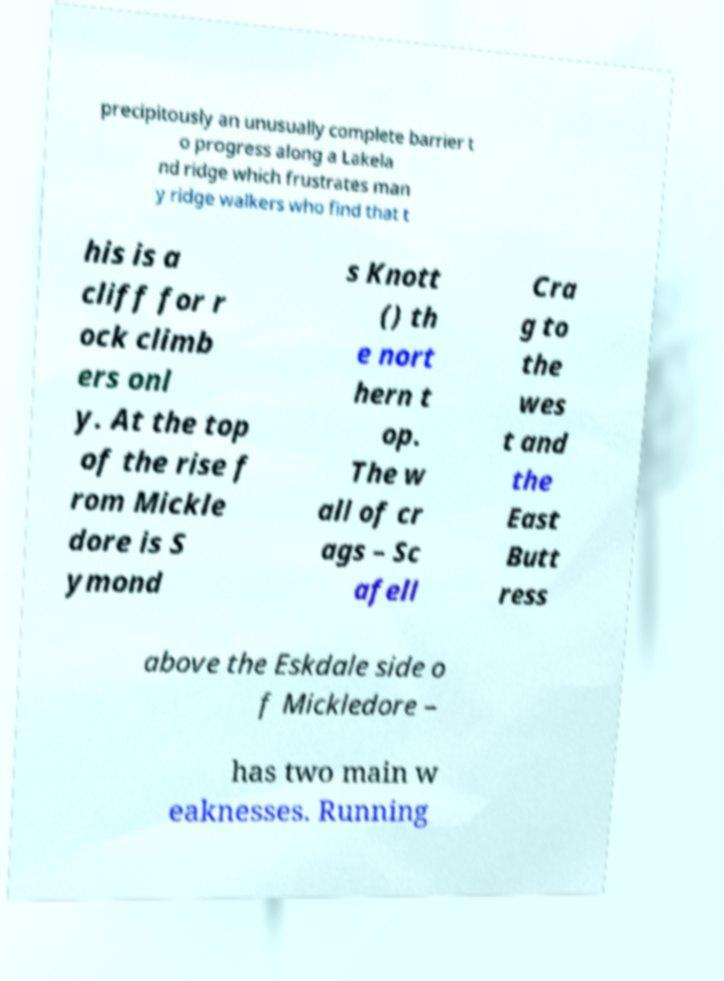There's text embedded in this image that I need extracted. Can you transcribe it verbatim? precipitously an unusually complete barrier t o progress along a Lakela nd ridge which frustrates man y ridge walkers who find that t his is a cliff for r ock climb ers onl y. At the top of the rise f rom Mickle dore is S ymond s Knott () th e nort hern t op. The w all of cr ags – Sc afell Cra g to the wes t and the East Butt ress above the Eskdale side o f Mickledore – has two main w eaknesses. Running 